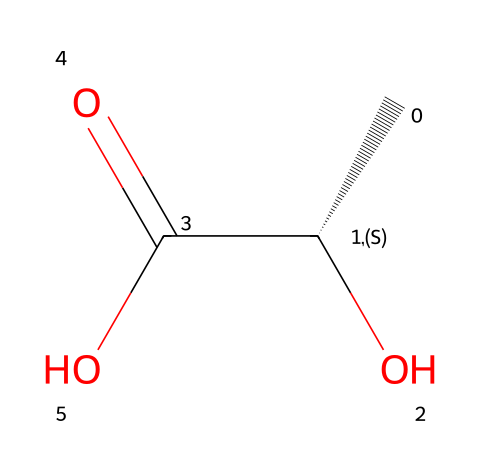What is the molecular formula of lactic acid? The SMILES representation indicates the presence of 3 carbon atoms (C), 6 hydrogen atoms (H), and 3 oxygen atoms (O). This gives the molecular formula C3H6O3.
Answer: C3H6O3 How many chiral centers does lactic acid have? The SMILES notation shows one chiral center located at the carbon atom that is attached to both a hydroxyl group and a carboxylic acid group, indicating a single asymmetric carbon.
Answer: 1 What functional groups are present in lactic acid? By analyzing the functional groups in the SMILES representation, we identify a hydroxyl group (–OH) and a carboxylic acid group (–COOH), which are characteristic of lactic acid.
Answer: hydroxyl and carboxylic acid What is the significance of the chiral configuration in lactic acid? The chiral configuration, indicated by the '@' symbol in the SMILES, designates that lactic acid exists in two enantiomeric forms (D- and L-lactic acid), which can have different biological activities and effects.
Answer: enantiomers Which type of isomerism does lactic acid exhibit? Given the presence of a chiral center, lactic acid exhibits optical isomerism, which is a type of isomerism related to the ability of the two enantiomers to rotate plane-polarized light in different directions.
Answer: optical isomerism What is the role of lactic acid in fermentation? Lactic acid is produced during fermentation as a byproduct of anaerobic respiration in certain microorganisms, playing a crucial role in energy production and preservation of organic materials.
Answer: byproduct of anaerobic respiration 